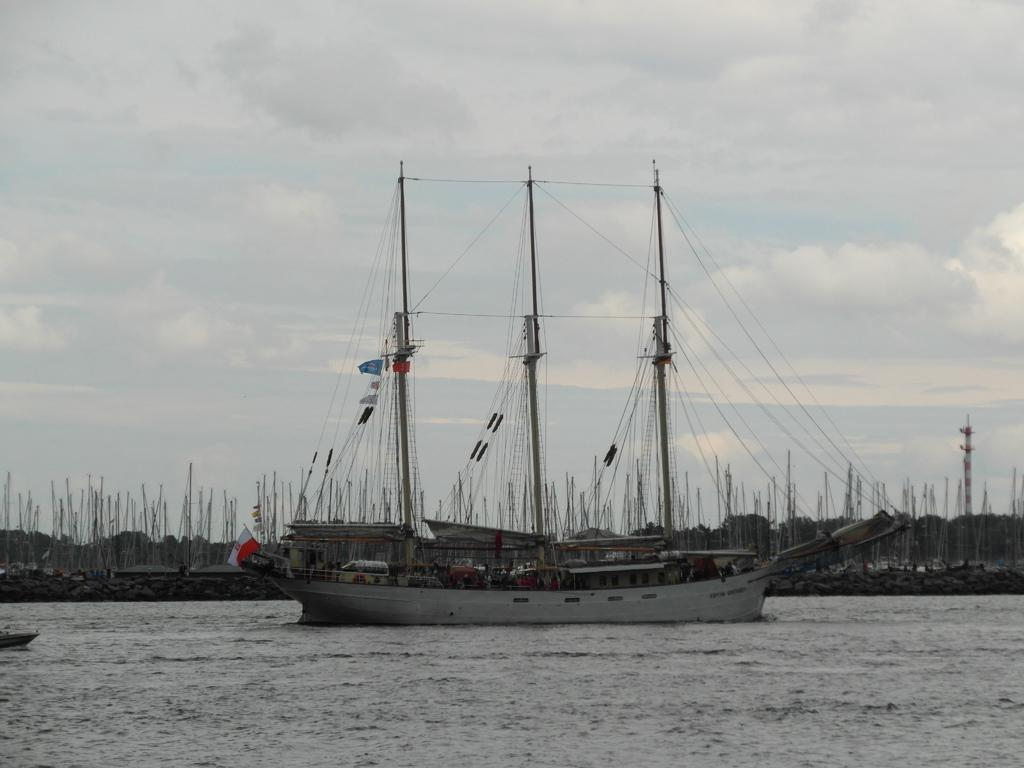What is the main subject of the image? The main subject of the image is a ship above the water. What can be seen flying on the ship? There is a flag in the image. What are the poles with strings used for? The poles with strings are likely used for raising or lowering the flag. What is visible in the background of the image? There are poles, trees, and the sky visible in the background of the image. What is the condition of the sky in the image? The sky is visible in the background of the image, and clouds are present. How many snakes are slithering on the ship in the image? There are no snakes present in the image; the focus is on the ship, flag, and poles with strings. What type of force is being applied to the ship in the image? There is no indication of any force being applied to the ship in the image; it is stationary above the water. 